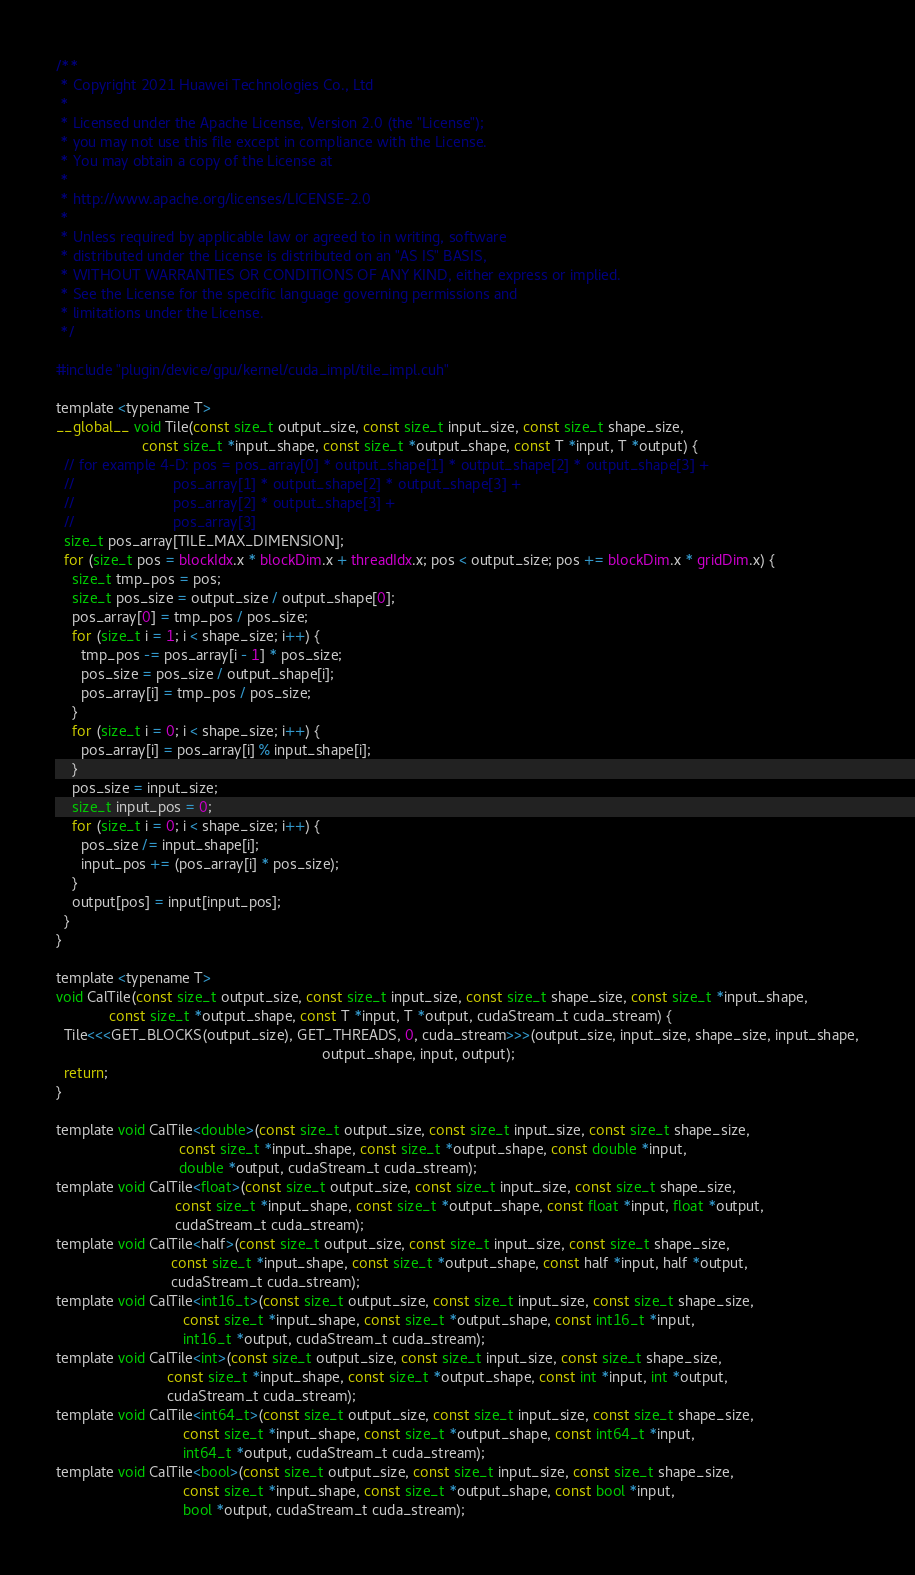Convert code to text. <code><loc_0><loc_0><loc_500><loc_500><_Cuda_>/**
 * Copyright 2021 Huawei Technologies Co., Ltd
 *
 * Licensed under the Apache License, Version 2.0 (the "License");
 * you may not use this file except in compliance with the License.
 * You may obtain a copy of the License at
 *
 * http://www.apache.org/licenses/LICENSE-2.0
 *
 * Unless required by applicable law or agreed to in writing, software
 * distributed under the License is distributed on an "AS IS" BASIS,
 * WITHOUT WARRANTIES OR CONDITIONS OF ANY KIND, either express or implied.
 * See the License for the specific language governing permissions and
 * limitations under the License.
 */

#include "plugin/device/gpu/kernel/cuda_impl/tile_impl.cuh"

template <typename T>
__global__ void Tile(const size_t output_size, const size_t input_size, const size_t shape_size,
                     const size_t *input_shape, const size_t *output_shape, const T *input, T *output) {
  // for example 4-D: pos = pos_array[0] * output_shape[1] * output_shape[2] * output_shape[3] +
  //                        pos_array[1] * output_shape[2] * output_shape[3] +
  //                        pos_array[2] * output_shape[3] +
  //                        pos_array[3]
  size_t pos_array[TILE_MAX_DIMENSION];
  for (size_t pos = blockIdx.x * blockDim.x + threadIdx.x; pos < output_size; pos += blockDim.x * gridDim.x) {
    size_t tmp_pos = pos;
    size_t pos_size = output_size / output_shape[0];
    pos_array[0] = tmp_pos / pos_size;
    for (size_t i = 1; i < shape_size; i++) {
      tmp_pos -= pos_array[i - 1] * pos_size;
      pos_size = pos_size / output_shape[i];
      pos_array[i] = tmp_pos / pos_size;
    }
    for (size_t i = 0; i < shape_size; i++) {
      pos_array[i] = pos_array[i] % input_shape[i];
    }
    pos_size = input_size;
    size_t input_pos = 0;
    for (size_t i = 0; i < shape_size; i++) {
      pos_size /= input_shape[i];
      input_pos += (pos_array[i] * pos_size);
    }
    output[pos] = input[input_pos];
  }
}

template <typename T>
void CalTile(const size_t output_size, const size_t input_size, const size_t shape_size, const size_t *input_shape,
             const size_t *output_shape, const T *input, T *output, cudaStream_t cuda_stream) {
  Tile<<<GET_BLOCKS(output_size), GET_THREADS, 0, cuda_stream>>>(output_size, input_size, shape_size, input_shape,
                                                                 output_shape, input, output);
  return;
}

template void CalTile<double>(const size_t output_size, const size_t input_size, const size_t shape_size,
                              const size_t *input_shape, const size_t *output_shape, const double *input,
                              double *output, cudaStream_t cuda_stream);
template void CalTile<float>(const size_t output_size, const size_t input_size, const size_t shape_size,
                             const size_t *input_shape, const size_t *output_shape, const float *input, float *output,
                             cudaStream_t cuda_stream);
template void CalTile<half>(const size_t output_size, const size_t input_size, const size_t shape_size,
                            const size_t *input_shape, const size_t *output_shape, const half *input, half *output,
                            cudaStream_t cuda_stream);
template void CalTile<int16_t>(const size_t output_size, const size_t input_size, const size_t shape_size,
                               const size_t *input_shape, const size_t *output_shape, const int16_t *input,
                               int16_t *output, cudaStream_t cuda_stream);
template void CalTile<int>(const size_t output_size, const size_t input_size, const size_t shape_size,
                           const size_t *input_shape, const size_t *output_shape, const int *input, int *output,
                           cudaStream_t cuda_stream);
template void CalTile<int64_t>(const size_t output_size, const size_t input_size, const size_t shape_size,
                               const size_t *input_shape, const size_t *output_shape, const int64_t *input,
                               int64_t *output, cudaStream_t cuda_stream);
template void CalTile<bool>(const size_t output_size, const size_t input_size, const size_t shape_size,
                               const size_t *input_shape, const size_t *output_shape, const bool *input,
                               bool *output, cudaStream_t cuda_stream);
</code> 